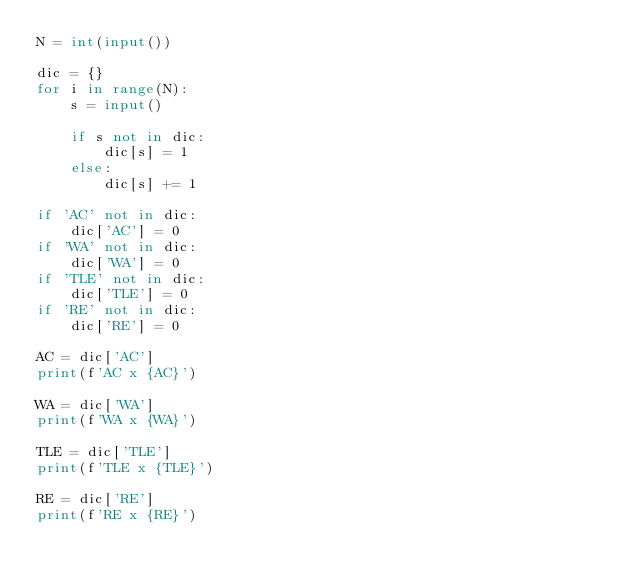<code> <loc_0><loc_0><loc_500><loc_500><_Python_>N = int(input())

dic = {}
for i in range(N):
    s = input()
    
    if s not in dic:
        dic[s] = 1
    else:
        dic[s] += 1

if 'AC' not in dic:
    dic['AC'] = 0
if 'WA' not in dic:
    dic['WA'] = 0
if 'TLE' not in dic:
    dic['TLE'] = 0
if 'RE' not in dic:
    dic['RE'] = 0
    
AC = dic['AC']
print(f'AC x {AC}')

WA = dic['WA']
print(f'WA x {WA}')

TLE = dic['TLE']
print(f'TLE x {TLE}')

RE = dic['RE']
print(f'RE x {RE}')</code> 